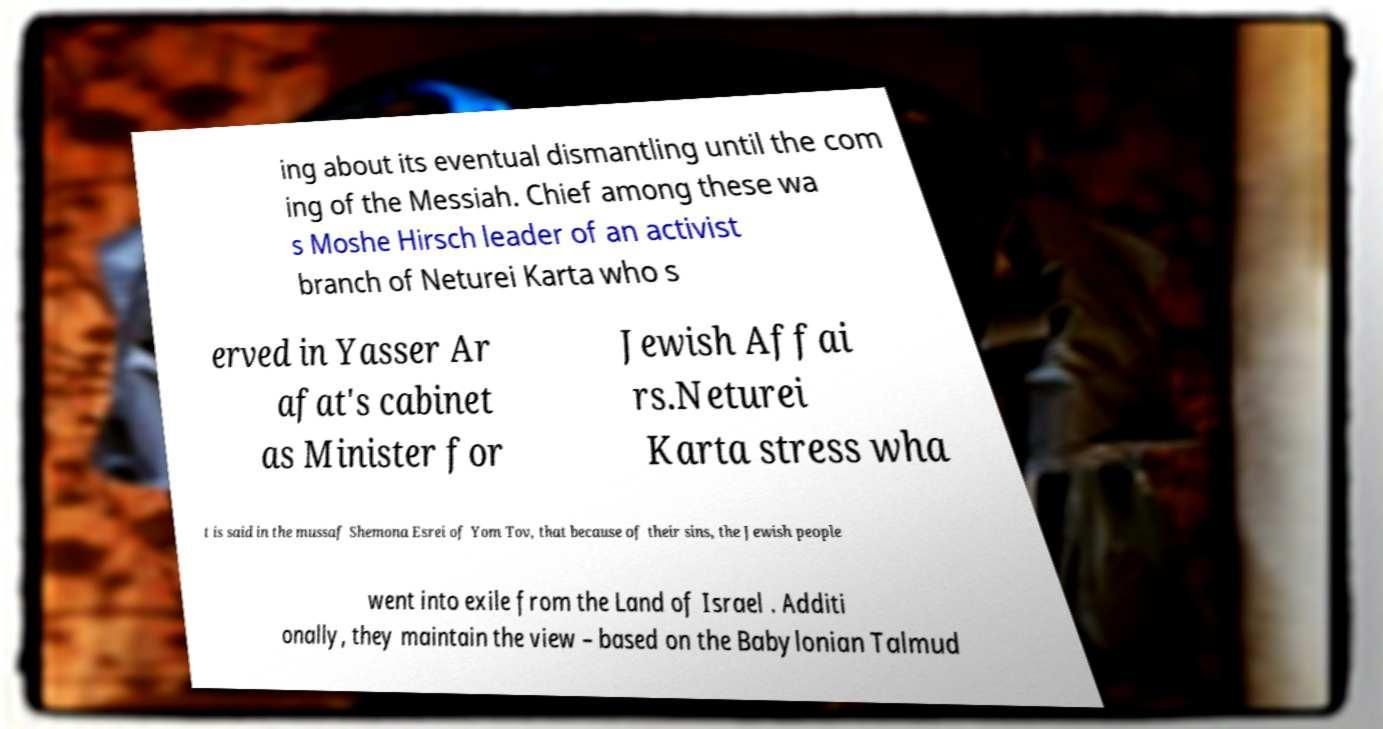I need the written content from this picture converted into text. Can you do that? ing about its eventual dismantling until the com ing of the Messiah. Chief among these wa s Moshe Hirsch leader of an activist branch of Neturei Karta who s erved in Yasser Ar afat's cabinet as Minister for Jewish Affai rs.Neturei Karta stress wha t is said in the mussaf Shemona Esrei of Yom Tov, that because of their sins, the Jewish people went into exile from the Land of Israel . Additi onally, they maintain the view – based on the Babylonian Talmud 